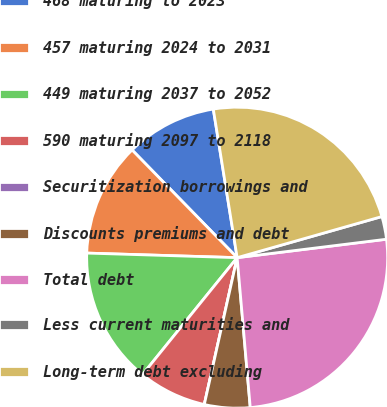<chart> <loc_0><loc_0><loc_500><loc_500><pie_chart><fcel>468 maturing to 2023<fcel>457 maturing 2024 to 2031<fcel>449 maturing 2037 to 2052<fcel>590 maturing 2097 to 2118<fcel>Securitization borrowings and<fcel>Discounts premiums and debt<fcel>Total debt<fcel>Less current maturities and<fcel>Long-term debt excluding<nl><fcel>9.77%<fcel>12.21%<fcel>14.65%<fcel>7.33%<fcel>0.0%<fcel>4.89%<fcel>25.57%<fcel>2.45%<fcel>23.13%<nl></chart> 